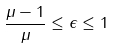Convert formula to latex. <formula><loc_0><loc_0><loc_500><loc_500>\frac { \mu - 1 } { \mu } \leq \epsilon \leq 1</formula> 